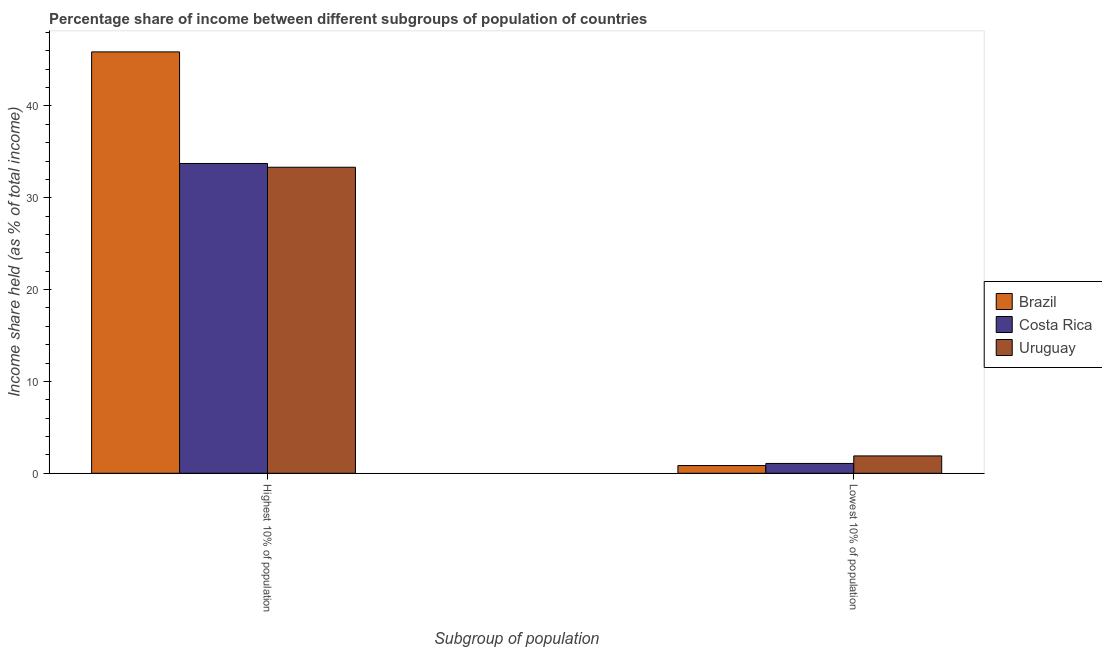Are the number of bars per tick equal to the number of legend labels?
Your answer should be compact. Yes. Are the number of bars on each tick of the X-axis equal?
Make the answer very short. Yes. How many bars are there on the 1st tick from the left?
Provide a succinct answer. 3. How many bars are there on the 2nd tick from the right?
Keep it short and to the point. 3. What is the label of the 2nd group of bars from the left?
Give a very brief answer. Lowest 10% of population. What is the income share held by highest 10% of the population in Brazil?
Your response must be concise. 45.88. Across all countries, what is the maximum income share held by lowest 10% of the population?
Your answer should be compact. 1.89. Across all countries, what is the minimum income share held by highest 10% of the population?
Offer a very short reply. 33.32. In which country was the income share held by highest 10% of the population maximum?
Your response must be concise. Brazil. In which country was the income share held by lowest 10% of the population minimum?
Your answer should be very brief. Brazil. What is the total income share held by lowest 10% of the population in the graph?
Provide a succinct answer. 3.8. What is the difference between the income share held by lowest 10% of the population in Uruguay and that in Brazil?
Offer a very short reply. 1.05. What is the difference between the income share held by lowest 10% of the population in Costa Rica and the income share held by highest 10% of the population in Uruguay?
Provide a succinct answer. -32.25. What is the average income share held by highest 10% of the population per country?
Your response must be concise. 37.64. What is the difference between the income share held by lowest 10% of the population and income share held by highest 10% of the population in Costa Rica?
Make the answer very short. -32.66. In how many countries, is the income share held by lowest 10% of the population greater than 42 %?
Your response must be concise. 0. What is the ratio of the income share held by highest 10% of the population in Costa Rica to that in Uruguay?
Give a very brief answer. 1.01. Is the income share held by lowest 10% of the population in Uruguay less than that in Costa Rica?
Give a very brief answer. No. In how many countries, is the income share held by highest 10% of the population greater than the average income share held by highest 10% of the population taken over all countries?
Your answer should be very brief. 1. What does the 3rd bar from the left in Highest 10% of population represents?
Keep it short and to the point. Uruguay. How many countries are there in the graph?
Your answer should be very brief. 3. Are the values on the major ticks of Y-axis written in scientific E-notation?
Keep it short and to the point. No. Does the graph contain any zero values?
Offer a very short reply. No. How many legend labels are there?
Provide a short and direct response. 3. What is the title of the graph?
Your response must be concise. Percentage share of income between different subgroups of population of countries. Does "Djibouti" appear as one of the legend labels in the graph?
Provide a short and direct response. No. What is the label or title of the X-axis?
Give a very brief answer. Subgroup of population. What is the label or title of the Y-axis?
Offer a terse response. Income share held (as % of total income). What is the Income share held (as % of total income) in Brazil in Highest 10% of population?
Your answer should be very brief. 45.88. What is the Income share held (as % of total income) in Costa Rica in Highest 10% of population?
Keep it short and to the point. 33.73. What is the Income share held (as % of total income) in Uruguay in Highest 10% of population?
Make the answer very short. 33.32. What is the Income share held (as % of total income) in Brazil in Lowest 10% of population?
Provide a succinct answer. 0.84. What is the Income share held (as % of total income) of Costa Rica in Lowest 10% of population?
Your response must be concise. 1.07. What is the Income share held (as % of total income) in Uruguay in Lowest 10% of population?
Provide a succinct answer. 1.89. Across all Subgroup of population, what is the maximum Income share held (as % of total income) in Brazil?
Your answer should be compact. 45.88. Across all Subgroup of population, what is the maximum Income share held (as % of total income) in Costa Rica?
Your response must be concise. 33.73. Across all Subgroup of population, what is the maximum Income share held (as % of total income) of Uruguay?
Keep it short and to the point. 33.32. Across all Subgroup of population, what is the minimum Income share held (as % of total income) in Brazil?
Offer a very short reply. 0.84. Across all Subgroup of population, what is the minimum Income share held (as % of total income) of Costa Rica?
Give a very brief answer. 1.07. Across all Subgroup of population, what is the minimum Income share held (as % of total income) in Uruguay?
Provide a succinct answer. 1.89. What is the total Income share held (as % of total income) of Brazil in the graph?
Your answer should be very brief. 46.72. What is the total Income share held (as % of total income) of Costa Rica in the graph?
Offer a terse response. 34.8. What is the total Income share held (as % of total income) of Uruguay in the graph?
Keep it short and to the point. 35.21. What is the difference between the Income share held (as % of total income) of Brazil in Highest 10% of population and that in Lowest 10% of population?
Offer a very short reply. 45.04. What is the difference between the Income share held (as % of total income) of Costa Rica in Highest 10% of population and that in Lowest 10% of population?
Offer a terse response. 32.66. What is the difference between the Income share held (as % of total income) of Uruguay in Highest 10% of population and that in Lowest 10% of population?
Provide a short and direct response. 31.43. What is the difference between the Income share held (as % of total income) of Brazil in Highest 10% of population and the Income share held (as % of total income) of Costa Rica in Lowest 10% of population?
Make the answer very short. 44.81. What is the difference between the Income share held (as % of total income) in Brazil in Highest 10% of population and the Income share held (as % of total income) in Uruguay in Lowest 10% of population?
Offer a terse response. 43.99. What is the difference between the Income share held (as % of total income) of Costa Rica in Highest 10% of population and the Income share held (as % of total income) of Uruguay in Lowest 10% of population?
Offer a very short reply. 31.84. What is the average Income share held (as % of total income) of Brazil per Subgroup of population?
Provide a short and direct response. 23.36. What is the average Income share held (as % of total income) of Uruguay per Subgroup of population?
Offer a very short reply. 17.61. What is the difference between the Income share held (as % of total income) of Brazil and Income share held (as % of total income) of Costa Rica in Highest 10% of population?
Keep it short and to the point. 12.15. What is the difference between the Income share held (as % of total income) of Brazil and Income share held (as % of total income) of Uruguay in Highest 10% of population?
Offer a very short reply. 12.56. What is the difference between the Income share held (as % of total income) in Costa Rica and Income share held (as % of total income) in Uruguay in Highest 10% of population?
Your answer should be very brief. 0.41. What is the difference between the Income share held (as % of total income) of Brazil and Income share held (as % of total income) of Costa Rica in Lowest 10% of population?
Give a very brief answer. -0.23. What is the difference between the Income share held (as % of total income) of Brazil and Income share held (as % of total income) of Uruguay in Lowest 10% of population?
Provide a succinct answer. -1.05. What is the difference between the Income share held (as % of total income) of Costa Rica and Income share held (as % of total income) of Uruguay in Lowest 10% of population?
Make the answer very short. -0.82. What is the ratio of the Income share held (as % of total income) in Brazil in Highest 10% of population to that in Lowest 10% of population?
Provide a short and direct response. 54.62. What is the ratio of the Income share held (as % of total income) of Costa Rica in Highest 10% of population to that in Lowest 10% of population?
Provide a succinct answer. 31.52. What is the ratio of the Income share held (as % of total income) in Uruguay in Highest 10% of population to that in Lowest 10% of population?
Make the answer very short. 17.63. What is the difference between the highest and the second highest Income share held (as % of total income) in Brazil?
Your answer should be very brief. 45.04. What is the difference between the highest and the second highest Income share held (as % of total income) of Costa Rica?
Give a very brief answer. 32.66. What is the difference between the highest and the second highest Income share held (as % of total income) in Uruguay?
Give a very brief answer. 31.43. What is the difference between the highest and the lowest Income share held (as % of total income) of Brazil?
Provide a succinct answer. 45.04. What is the difference between the highest and the lowest Income share held (as % of total income) in Costa Rica?
Ensure brevity in your answer.  32.66. What is the difference between the highest and the lowest Income share held (as % of total income) in Uruguay?
Give a very brief answer. 31.43. 